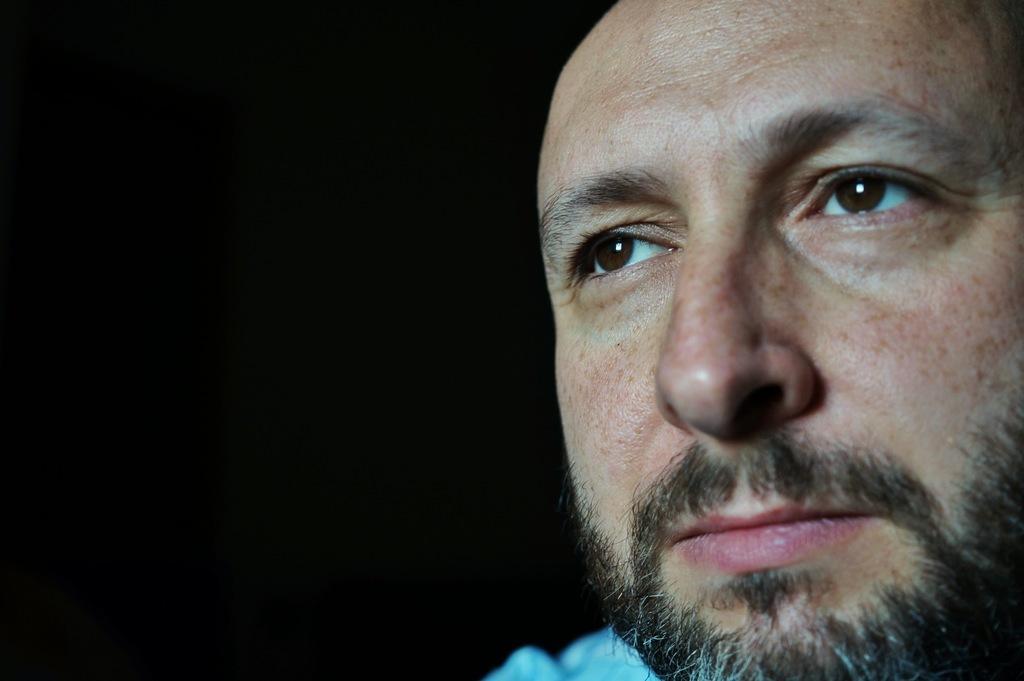In one or two sentences, can you explain what this image depicts? In this image we can see some person's face. 